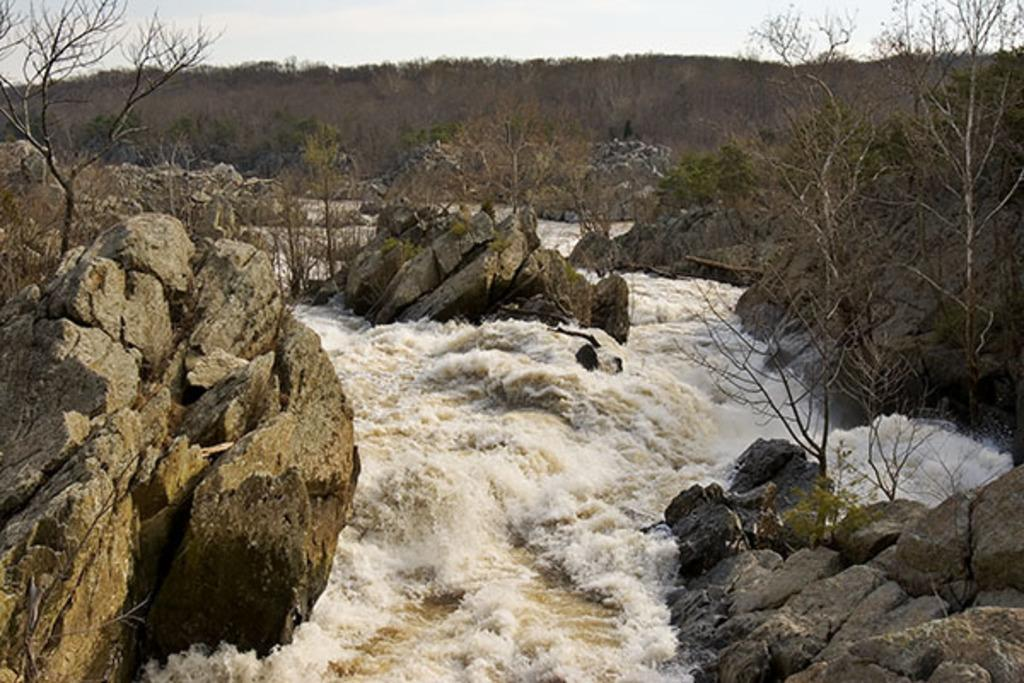What is happening in the image? There is water flow in the image. What objects can be seen in the water flow? There are rocks in the image. What type of vegetation is present in the image? There are plants in the image. What can be seen in the background of the image? There are trees and the sky visible in the background of the image. What type of needle is being used to sew the band in the image? There is no needle or band present in the image; it features water flow, rocks, plants, trees, and the sky. 